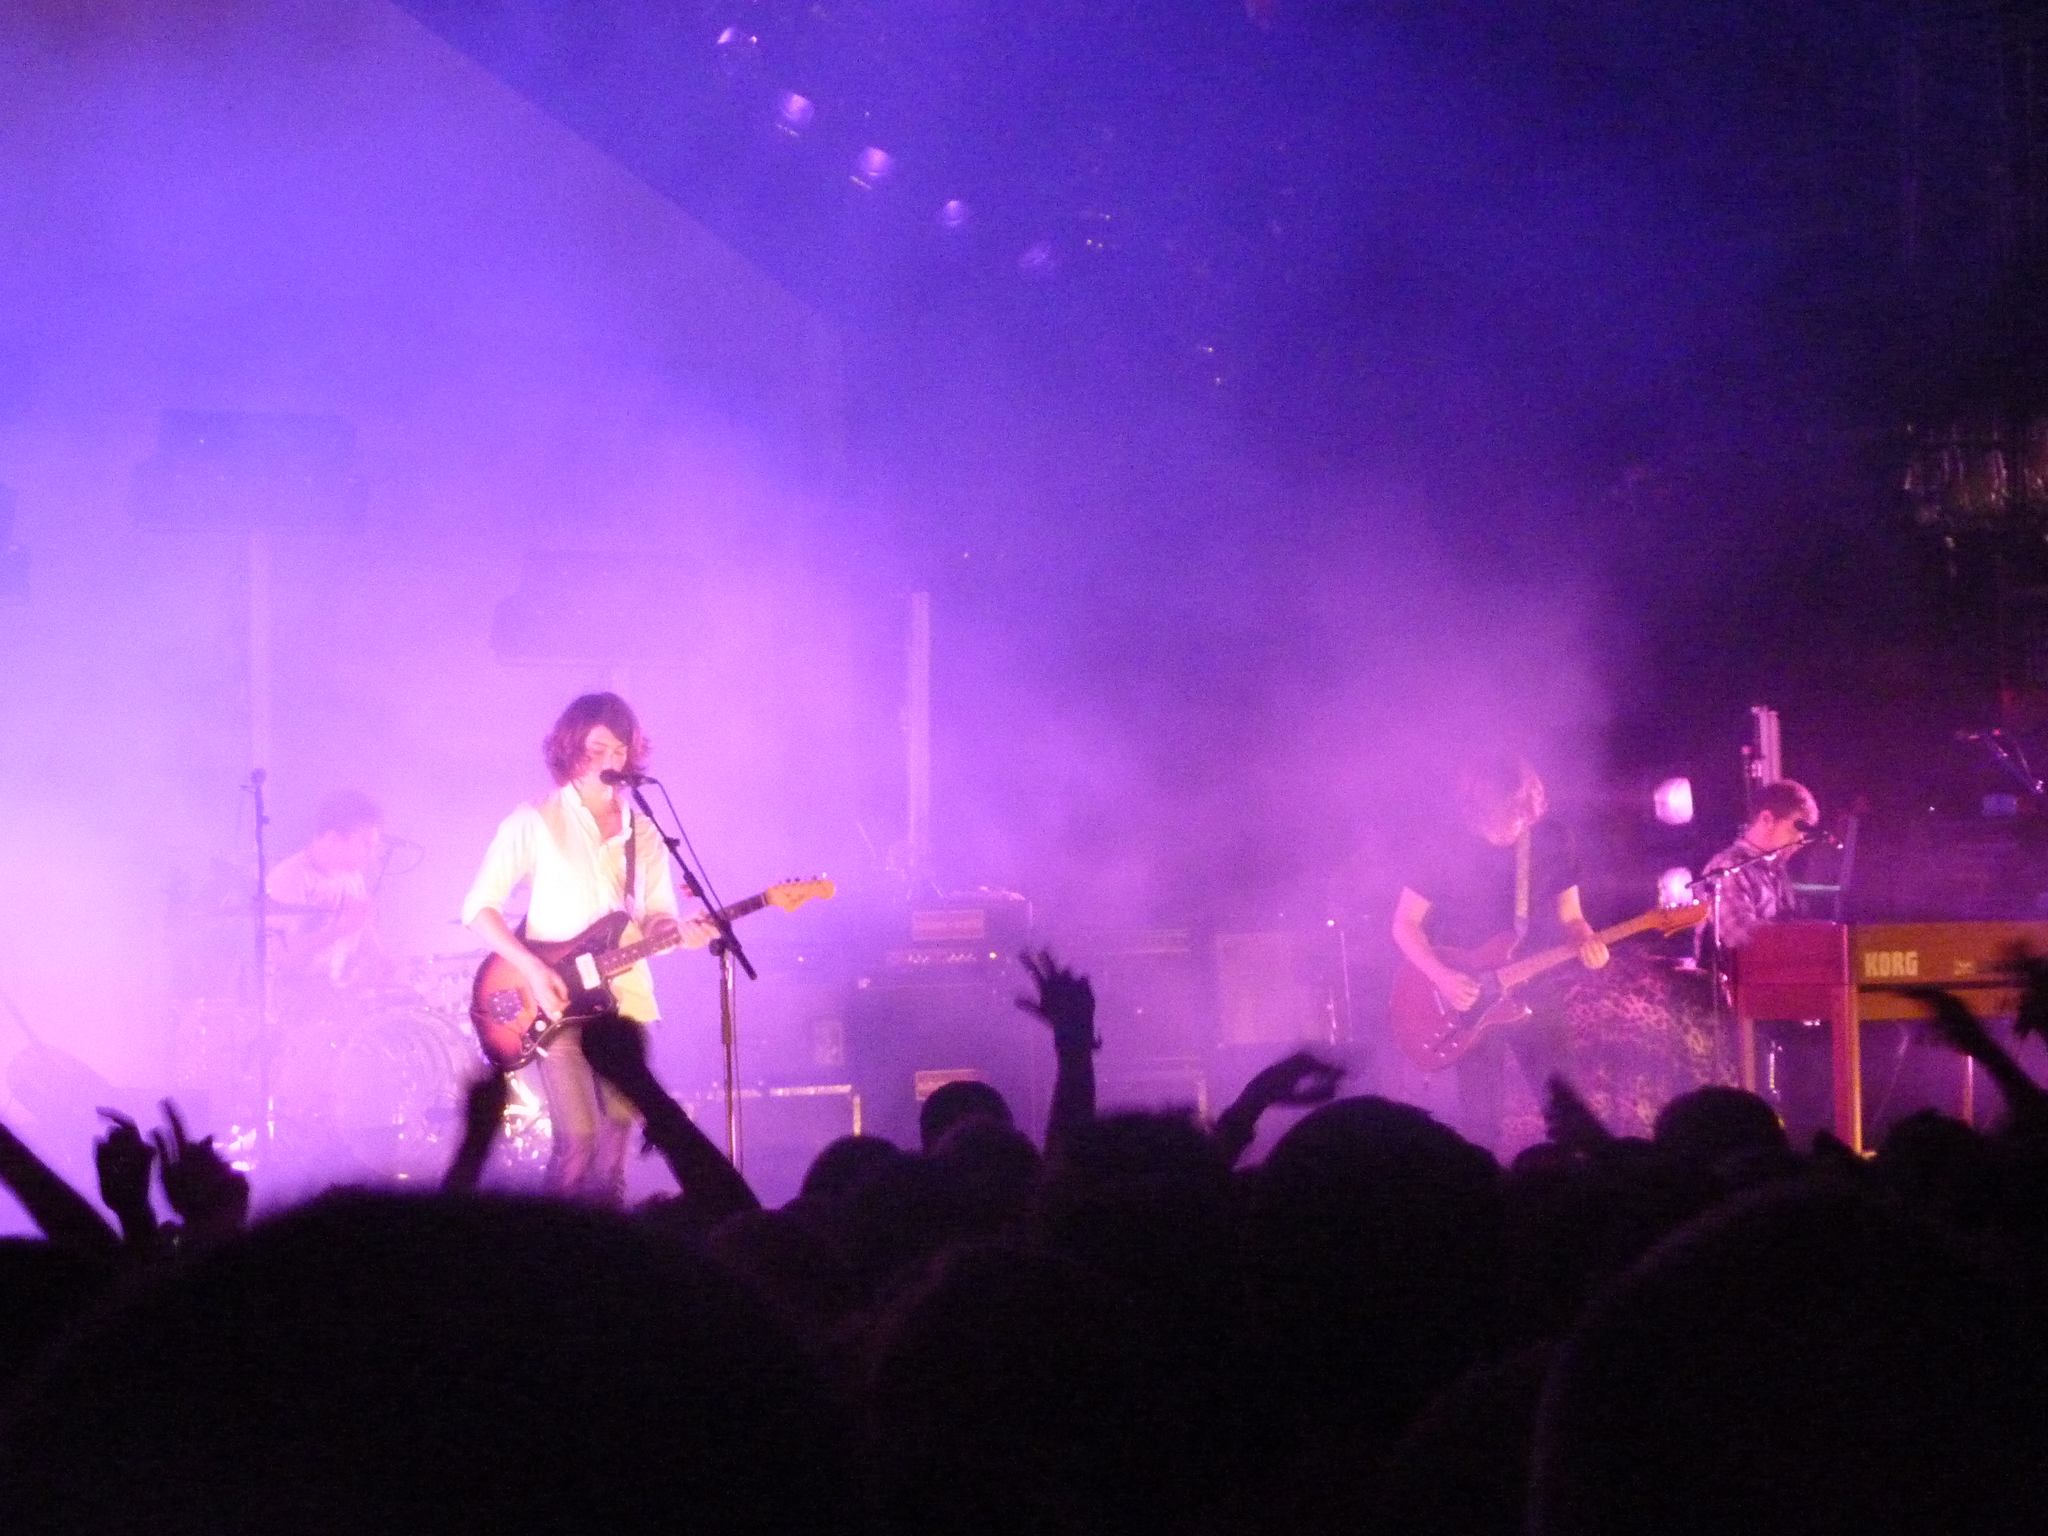Describe this image in one or two sentences. Here we can see a band performing on a stage, on the right side we can see a person playing piano and the person in the middle is playing a guitar, the person on the left side is singing a song and playing a guitar with microphone present in front of her and there is another person who is playing drums and in front of them we can see audience present 